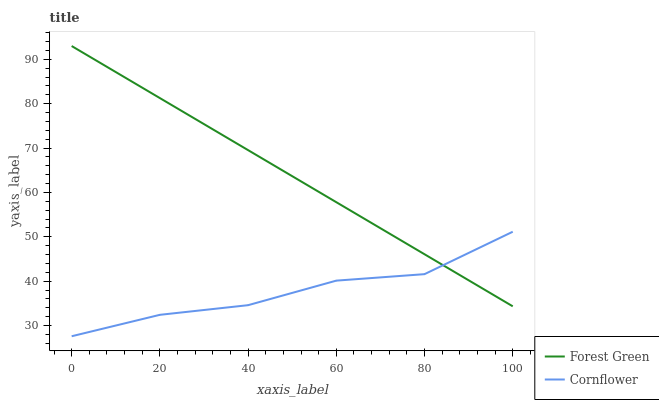Does Forest Green have the minimum area under the curve?
Answer yes or no. No. Is Forest Green the roughest?
Answer yes or no. No. Does Forest Green have the lowest value?
Answer yes or no. No. 